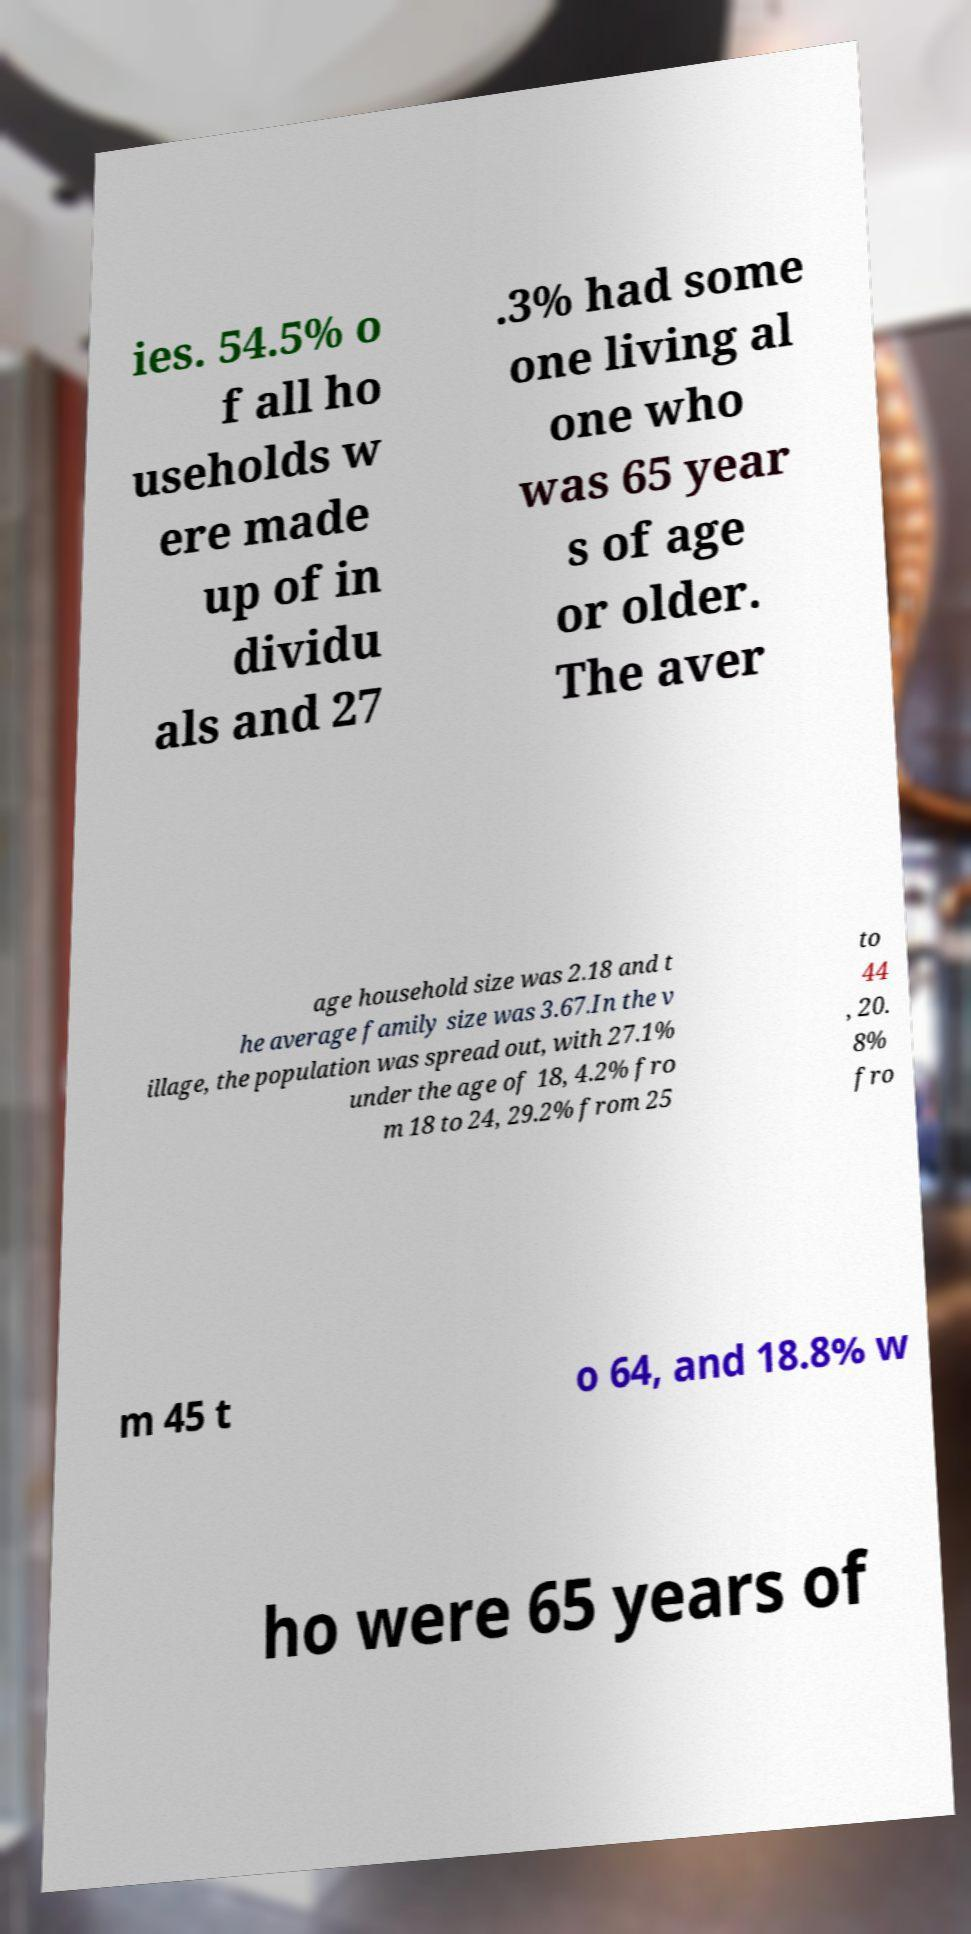Can you accurately transcribe the text from the provided image for me? ies. 54.5% o f all ho useholds w ere made up of in dividu als and 27 .3% had some one living al one who was 65 year s of age or older. The aver age household size was 2.18 and t he average family size was 3.67.In the v illage, the population was spread out, with 27.1% under the age of 18, 4.2% fro m 18 to 24, 29.2% from 25 to 44 , 20. 8% fro m 45 t o 64, and 18.8% w ho were 65 years of 